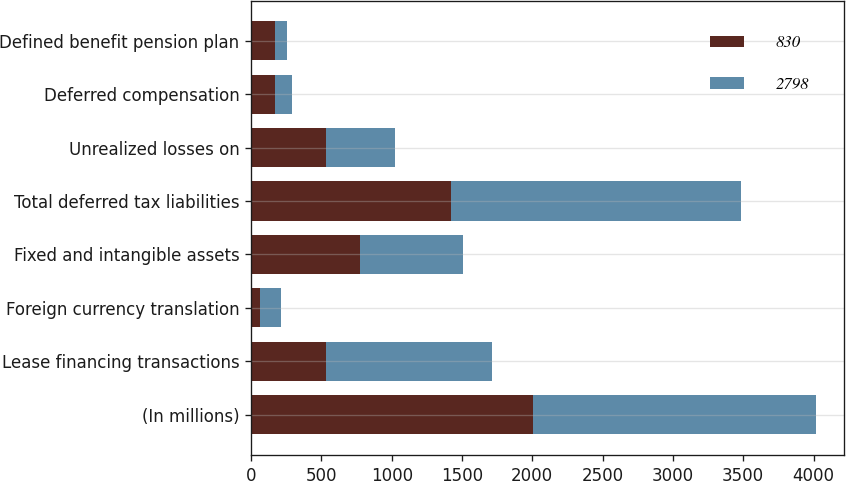<chart> <loc_0><loc_0><loc_500><loc_500><stacked_bar_chart><ecel><fcel>(In millions)<fcel>Lease financing transactions<fcel>Foreign currency translation<fcel>Fixed and intangible assets<fcel>Total deferred tax liabilities<fcel>Unrealized losses on<fcel>Deferred compensation<fcel>Defined benefit pension plan<nl><fcel>830<fcel>2008<fcel>535<fcel>63<fcel>775<fcel>1424<fcel>535<fcel>172<fcel>169<nl><fcel>2798<fcel>2007<fcel>1177<fcel>152<fcel>731<fcel>2060<fcel>486<fcel>122<fcel>85<nl></chart> 